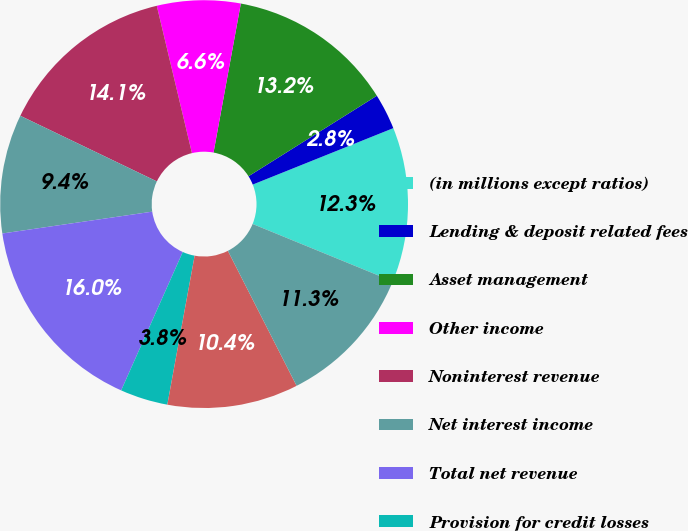Convert chart. <chart><loc_0><loc_0><loc_500><loc_500><pie_chart><fcel>(in millions except ratios)<fcel>Lending & deposit related fees<fcel>Asset management<fcel>Other income<fcel>Noninterest revenue<fcel>Net interest income<fcel>Total net revenue<fcel>Provision for credit losses<fcel>Compensation expense<fcel>Noncompensation expense<nl><fcel>12.26%<fcel>2.84%<fcel>13.2%<fcel>6.61%<fcel>14.14%<fcel>9.43%<fcel>16.03%<fcel>3.78%<fcel>10.38%<fcel>11.32%<nl></chart> 